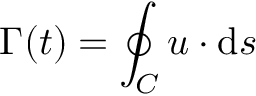<formula> <loc_0><loc_0><loc_500><loc_500>\Gamma ( t ) = \oint _ { C } { u } \cdot d { s }</formula> 